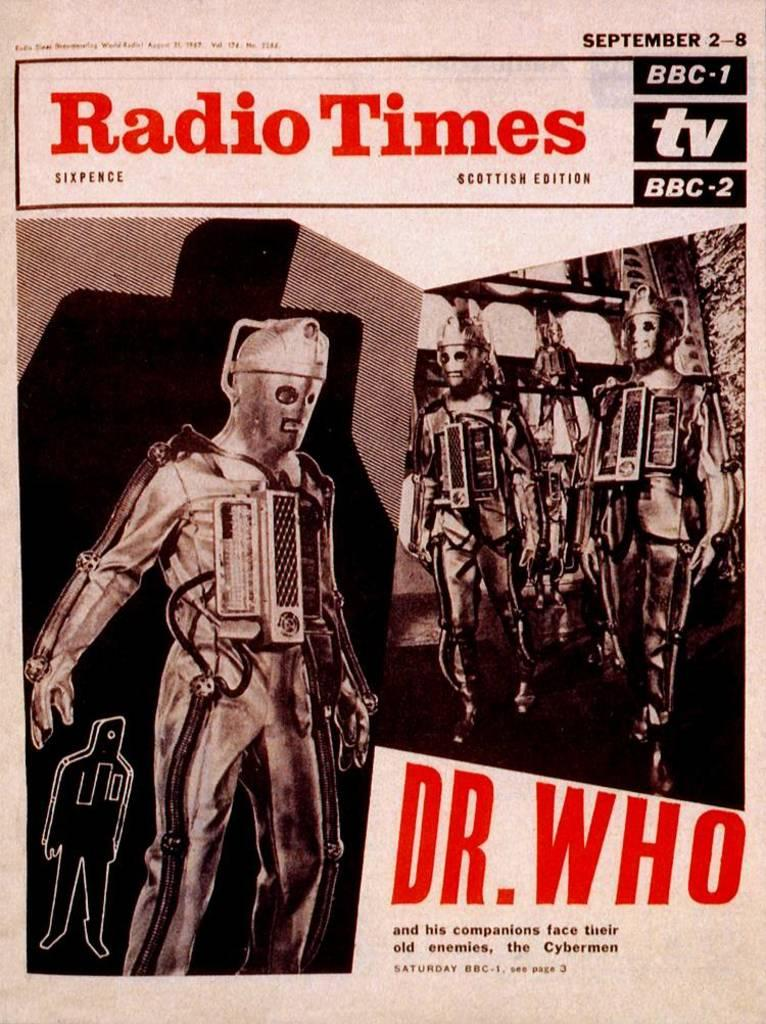<image>
Provide a brief description of the given image. Poster for Radio Times that talks about Dr. Who 